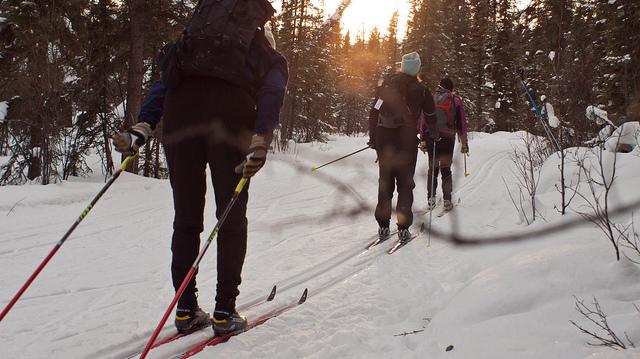What sport is this?
Quick response, please. Skiing. How many people are skiing?
Give a very brief answer. 3. Are skier facing the same direction?
Quick response, please. Yes. 